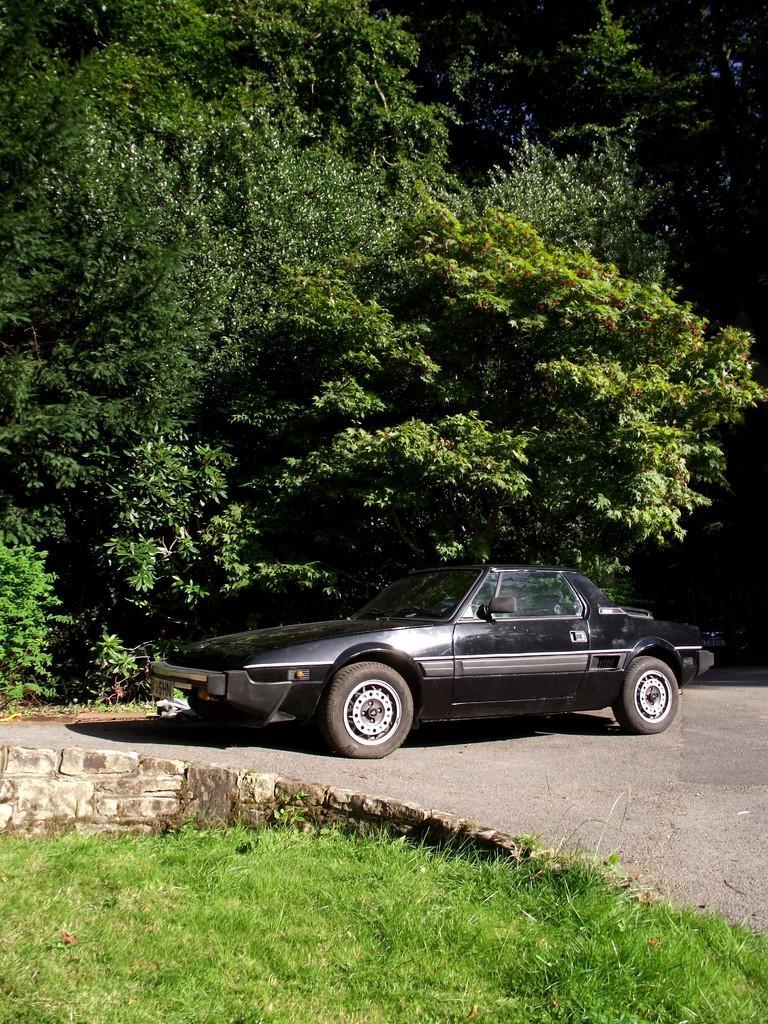Could you give a brief overview of what you see in this image? In this image I can see the vehicle in black color. In the background I can see few trees in green color. 